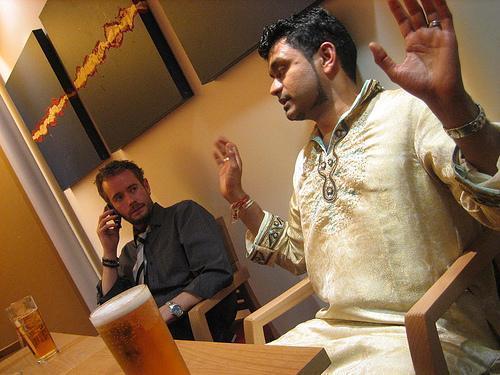How many people are raising hands?
Give a very brief answer. 1. How many people are in the picture?
Give a very brief answer. 2. How many motorcycles have two helmets?
Give a very brief answer. 0. 